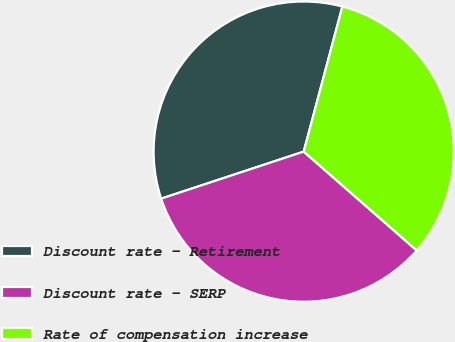Convert chart to OTSL. <chart><loc_0><loc_0><loc_500><loc_500><pie_chart><fcel>Discount rate - Retirement<fcel>Discount rate - SERP<fcel>Rate of compensation increase<nl><fcel>34.22%<fcel>33.49%<fcel>32.29%<nl></chart> 